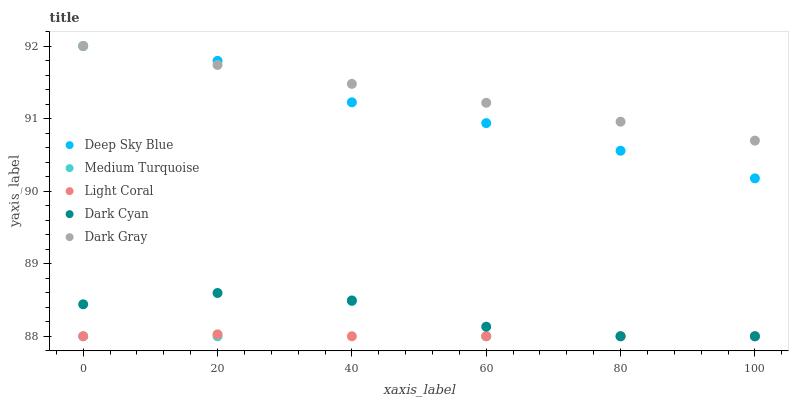Does Light Coral have the minimum area under the curve?
Answer yes or no. Yes. Does Dark Gray have the maximum area under the curve?
Answer yes or no. Yes. Does Dark Cyan have the minimum area under the curve?
Answer yes or no. No. Does Dark Cyan have the maximum area under the curve?
Answer yes or no. No. Is Dark Gray the smoothest?
Answer yes or no. Yes. Is Medium Turquoise the roughest?
Answer yes or no. Yes. Is Dark Cyan the smoothest?
Answer yes or no. No. Is Dark Cyan the roughest?
Answer yes or no. No. Does Light Coral have the lowest value?
Answer yes or no. Yes. Does Dark Gray have the lowest value?
Answer yes or no. No. Does Deep Sky Blue have the highest value?
Answer yes or no. Yes. Does Dark Cyan have the highest value?
Answer yes or no. No. Is Medium Turquoise less than Deep Sky Blue?
Answer yes or no. Yes. Is Deep Sky Blue greater than Dark Cyan?
Answer yes or no. Yes. Does Light Coral intersect Dark Cyan?
Answer yes or no. Yes. Is Light Coral less than Dark Cyan?
Answer yes or no. No. Is Light Coral greater than Dark Cyan?
Answer yes or no. No. Does Medium Turquoise intersect Deep Sky Blue?
Answer yes or no. No. 